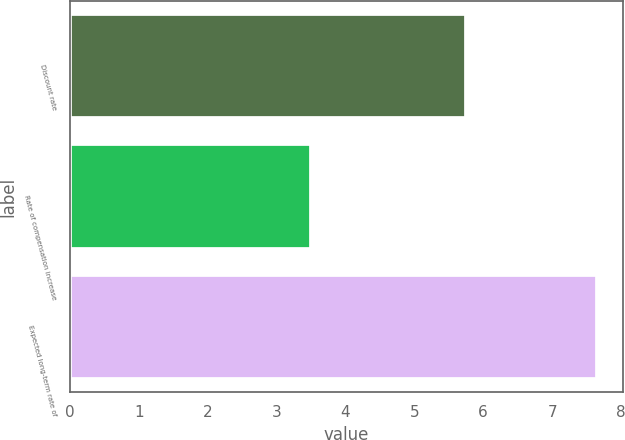<chart> <loc_0><loc_0><loc_500><loc_500><bar_chart><fcel>Discount rate<fcel>Rate of compensation increase<fcel>Expected long-term rate of<nl><fcel>5.75<fcel>3.5<fcel>7.65<nl></chart> 